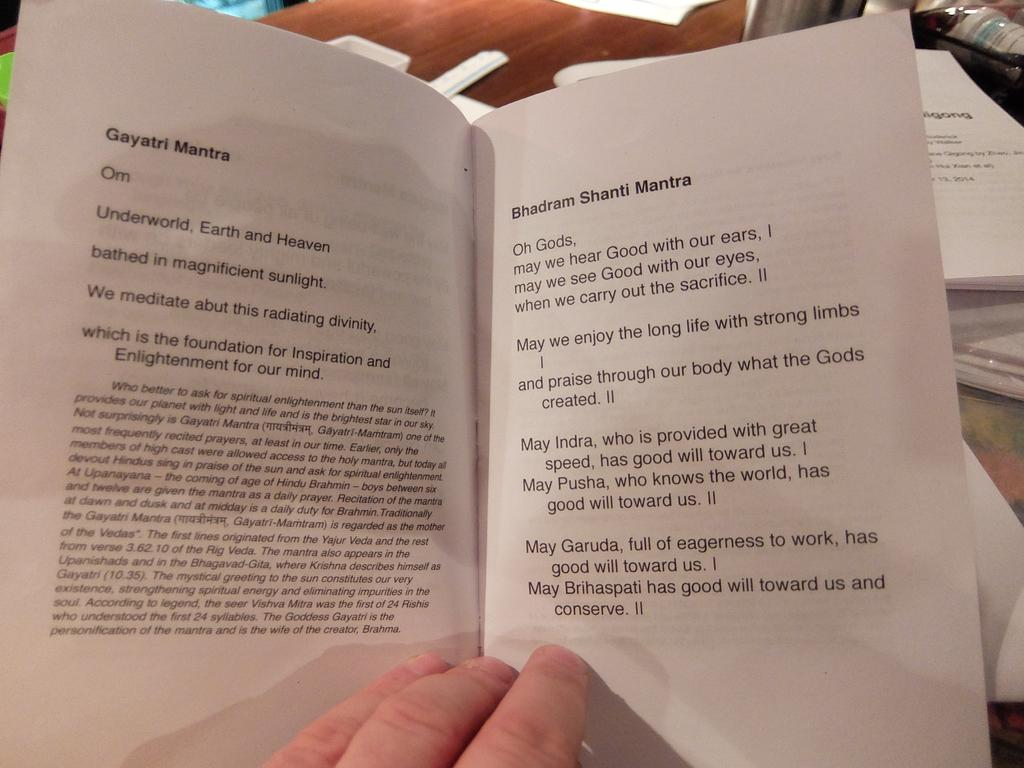<image>
Offer a succinct explanation of the picture presented. A person holding open a book with the heading Gayatri Mantra at the top. 